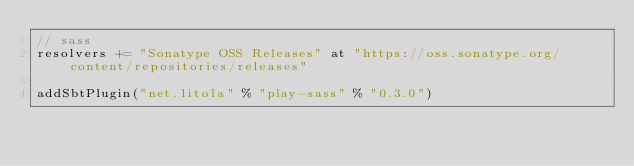<code> <loc_0><loc_0><loc_500><loc_500><_Scala_>// sass
resolvers += "Sonatype OSS Releases" at "https://oss.sonatype.org/content/repositories/releases"

addSbtPlugin("net.litola" % "play-sass" % "0.3.0")
</code> 